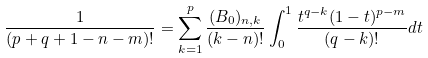<formula> <loc_0><loc_0><loc_500><loc_500>\frac { 1 } { ( p + q + 1 - n - m ) ! } = \sum _ { k = 1 } ^ { p } \frac { ( B _ { 0 } ) _ { n , k } } { ( k - n ) ! } \int _ { 0 } ^ { 1 } \frac { t ^ { q - k } ( 1 - t ) ^ { p - m } } { ( q - k ) ! } d t</formula> 